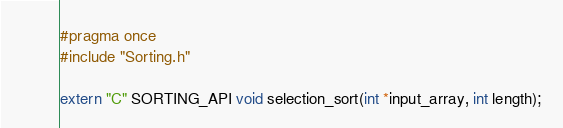<code> <loc_0><loc_0><loc_500><loc_500><_C_>#pragma once
#include "Sorting.h"

extern "C" SORTING_API void selection_sort(int *input_array, int length);</code> 